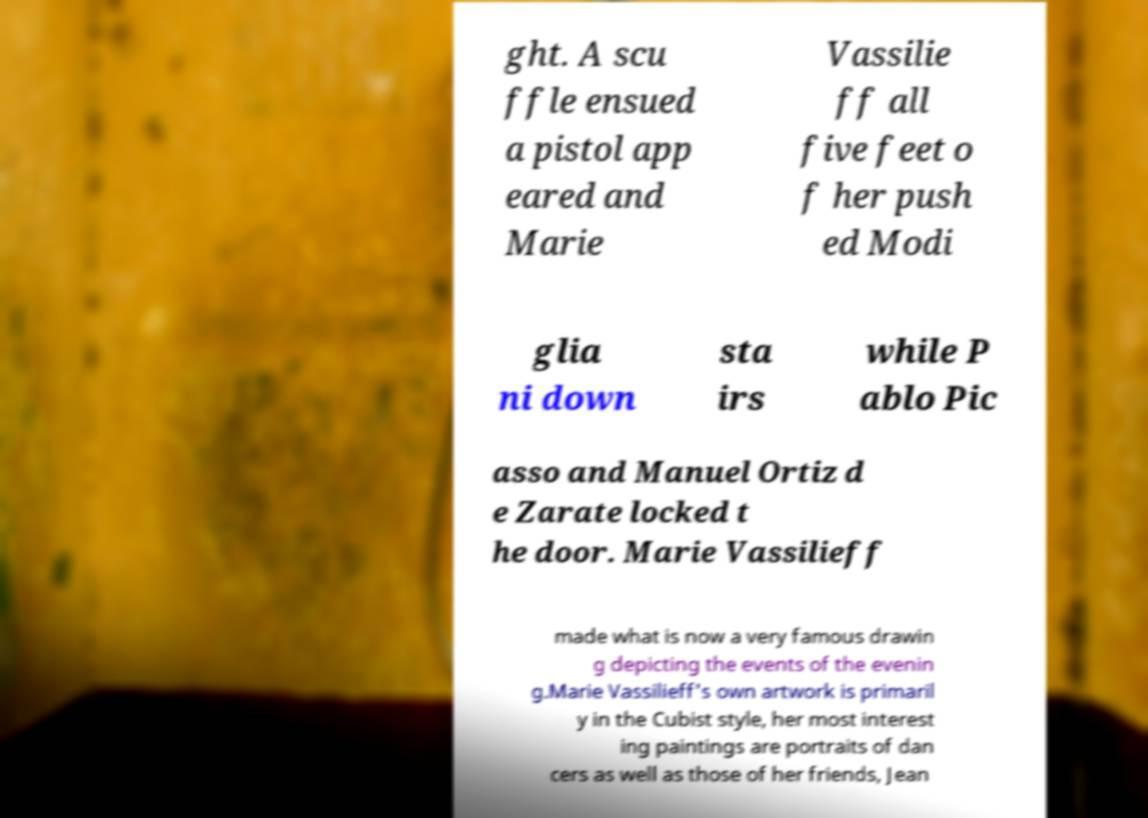Can you accurately transcribe the text from the provided image for me? ght. A scu ffle ensued a pistol app eared and Marie Vassilie ff all five feet o f her push ed Modi glia ni down sta irs while P ablo Pic asso and Manuel Ortiz d e Zarate locked t he door. Marie Vassilieff made what is now a very famous drawin g depicting the events of the evenin g.Marie Vassilieff's own artwork is primaril y in the Cubist style, her most interest ing paintings are portraits of dan cers as well as those of her friends, Jean 